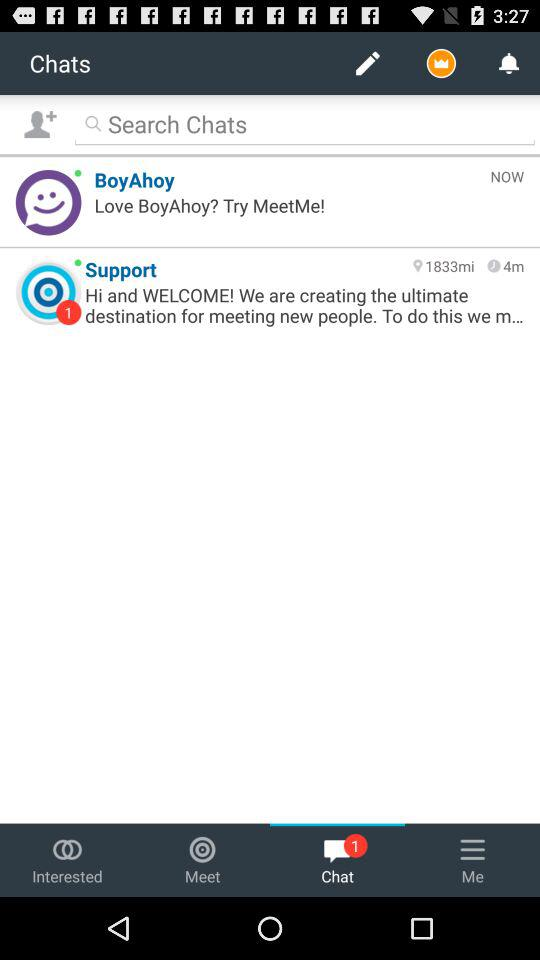How many unread chats are there? There is 1 unread chat. 